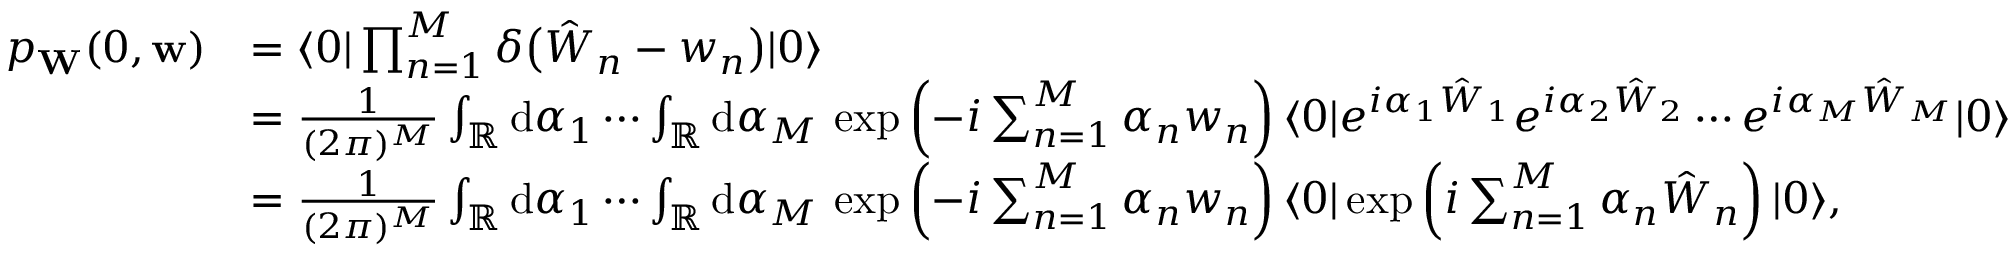Convert formula to latex. <formula><loc_0><loc_0><loc_500><loc_500>\begin{array} { r l } { p _ { W } ( 0 , w ) } & { = \langle 0 | \prod _ { n = 1 } ^ { M } \delta \left ( \hat { W } _ { n } - w _ { n } \right ) | 0 \rangle } \\ & { = \frac { 1 } { ( 2 \pi ) ^ { M } } \int _ { \mathbb { R } } d \alpha _ { 1 } \cdots \int _ { \mathbb { R } } d \alpha _ { M } \, \exp \left ( - i \sum _ { n = 1 } ^ { M } \alpha _ { n } w _ { n } \right ) \langle 0 | e ^ { i \alpha _ { 1 } \hat { W } _ { 1 } } e ^ { i \alpha _ { 2 } \hat { W } _ { 2 } } \cdots e ^ { i \alpha _ { M } \hat { W } _ { M } } | 0 \rangle } \\ & { = \frac { 1 } { ( 2 \pi ) ^ { M } } \int _ { \mathbb { R } } d \alpha _ { 1 } \cdots \int _ { \mathbb { R } } d \alpha _ { M } \, \exp \left ( - i \sum _ { n = 1 } ^ { M } \alpha _ { n } w _ { n } \right ) \langle 0 | \exp \left ( i \sum _ { n = 1 } ^ { M } \alpha _ { n } \hat { W } _ { n } \right ) | 0 \rangle , } \end{array}</formula> 